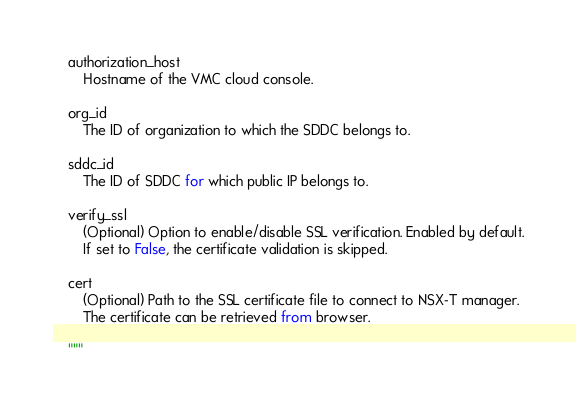<code> <loc_0><loc_0><loc_500><loc_500><_Python_>
    authorization_host
        Hostname of the VMC cloud console.

    org_id
        The ID of organization to which the SDDC belongs to.

    sddc_id
        The ID of SDDC for which public IP belongs to.

    verify_ssl
        (Optional) Option to enable/disable SSL verification. Enabled by default.
        If set to False, the certificate validation is skipped.

    cert
        (Optional) Path to the SSL certificate file to connect to NSX-T manager.
        The certificate can be retrieved from browser.

    """</code> 